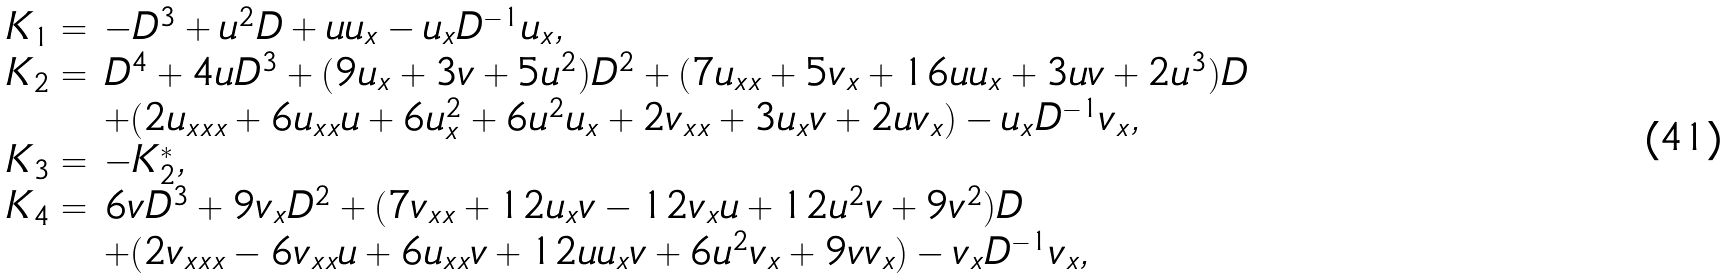Convert formula to latex. <formula><loc_0><loc_0><loc_500><loc_500>\begin{array} { l l } K _ { 1 } = & - D ^ { 3 } + u ^ { 2 } D + u u _ { x } - u _ { x } D ^ { - 1 } u _ { x } , \\ K _ { 2 } = & D ^ { 4 } + 4 u D ^ { 3 } + ( 9 u _ { x } + 3 v + 5 u ^ { 2 } ) D ^ { 2 } + ( 7 u _ { x x } + 5 v _ { x } + 1 6 u u _ { x } + 3 u v + 2 u ^ { 3 } ) D \\ & + ( 2 u _ { x x x } + 6 u _ { x x } u + 6 u _ { x } ^ { 2 } + 6 u ^ { 2 } u _ { x } + 2 v _ { x x } + 3 u _ { x } v + 2 u v _ { x } ) - u _ { x } D ^ { - 1 } v _ { x } , \\ K _ { 3 } = & - K ^ { * } _ { 2 } , \\ K _ { 4 } = & 6 v D ^ { 3 } + 9 v _ { x } D ^ { 2 } + ( 7 v _ { x x } + 1 2 u _ { x } v - 1 2 v _ { x } u + 1 2 u ^ { 2 } v + 9 v ^ { 2 } ) D \\ & + ( 2 v _ { x x x } - 6 v _ { x x } u + 6 u _ { x x } v + 1 2 u u _ { x } v + 6 u ^ { 2 } v _ { x } + 9 v v _ { x } ) - v _ { x } D ^ { - 1 } v _ { x } , \end{array}</formula> 